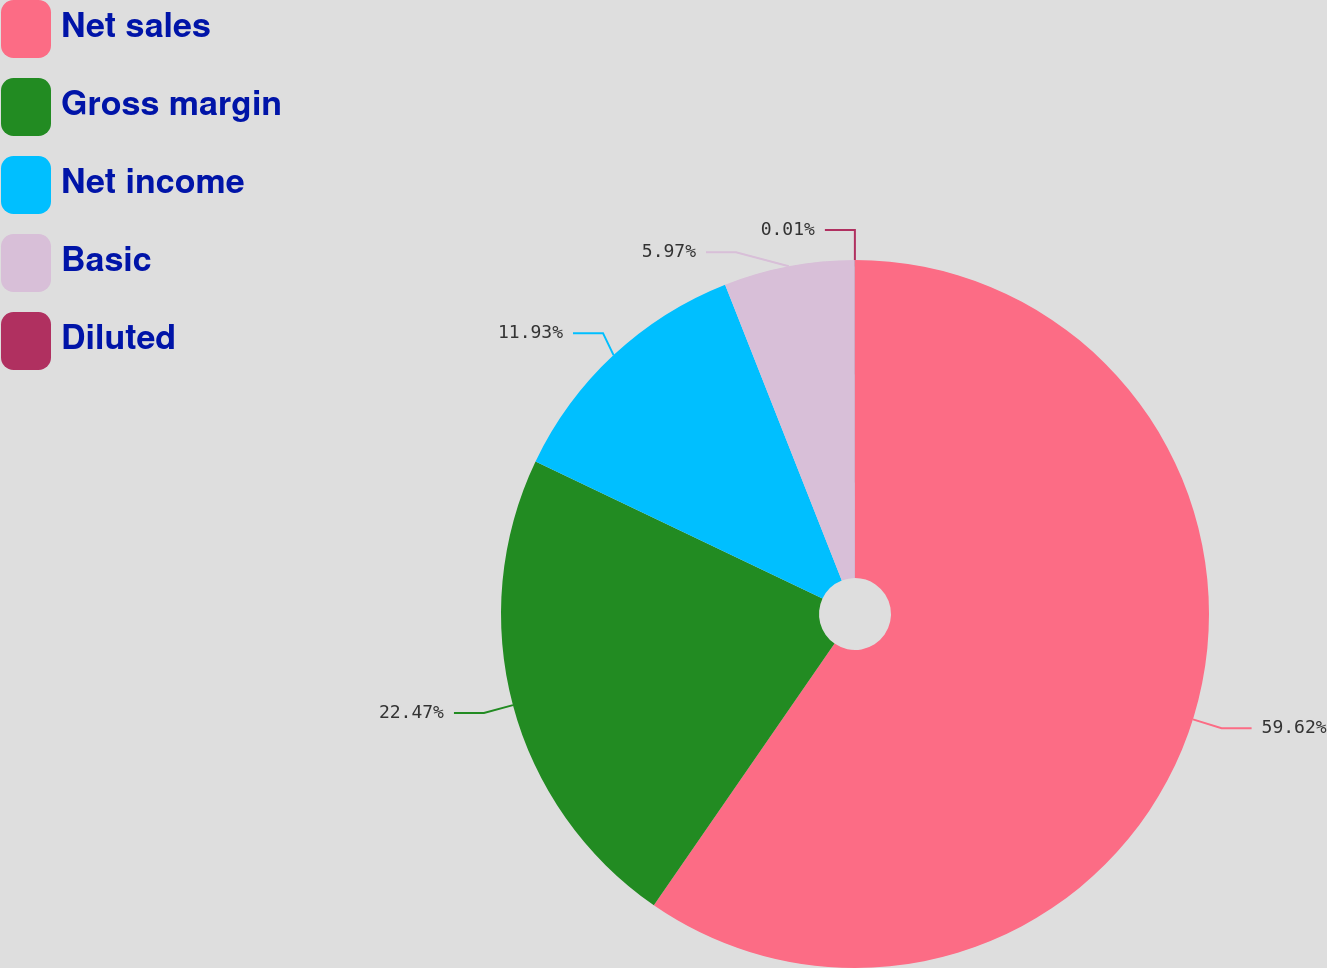Convert chart. <chart><loc_0><loc_0><loc_500><loc_500><pie_chart><fcel>Net sales<fcel>Gross margin<fcel>Net income<fcel>Basic<fcel>Diluted<nl><fcel>59.62%<fcel>22.47%<fcel>11.93%<fcel>5.97%<fcel>0.01%<nl></chart> 